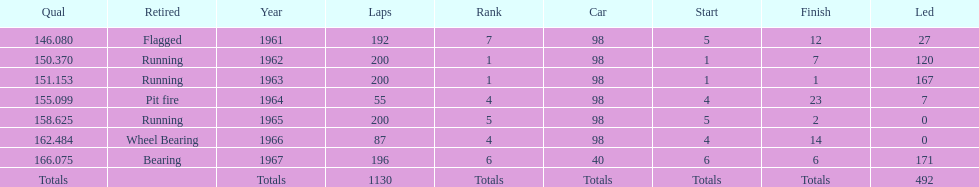In which years did he lead the race the least? 1965, 1966. 